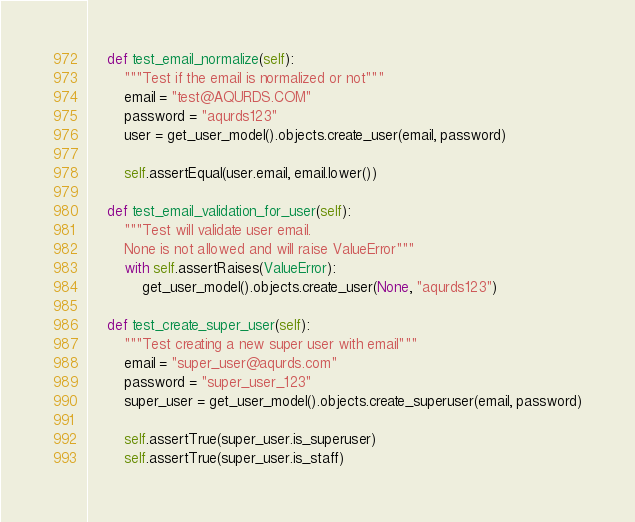<code> <loc_0><loc_0><loc_500><loc_500><_Python_>    def test_email_normalize(self):
        """Test if the email is normalized or not"""
        email = "test@AQURDS.COM"
        password = "aqurds123"
        user = get_user_model().objects.create_user(email, password)

        self.assertEqual(user.email, email.lower())

    def test_email_validation_for_user(self):
        """Test will validate user email.
        None is not allowed and will raise ValueError"""
        with self.assertRaises(ValueError):
            get_user_model().objects.create_user(None, "aqurds123")

    def test_create_super_user(self):
        """Test creating a new super user with email"""
        email = "super_user@aqurds.com"
        password = "super_user_123"
        super_user = get_user_model().objects.create_superuser(email, password)

        self.assertTrue(super_user.is_superuser)
        self.assertTrue(super_user.is_staff)
</code> 